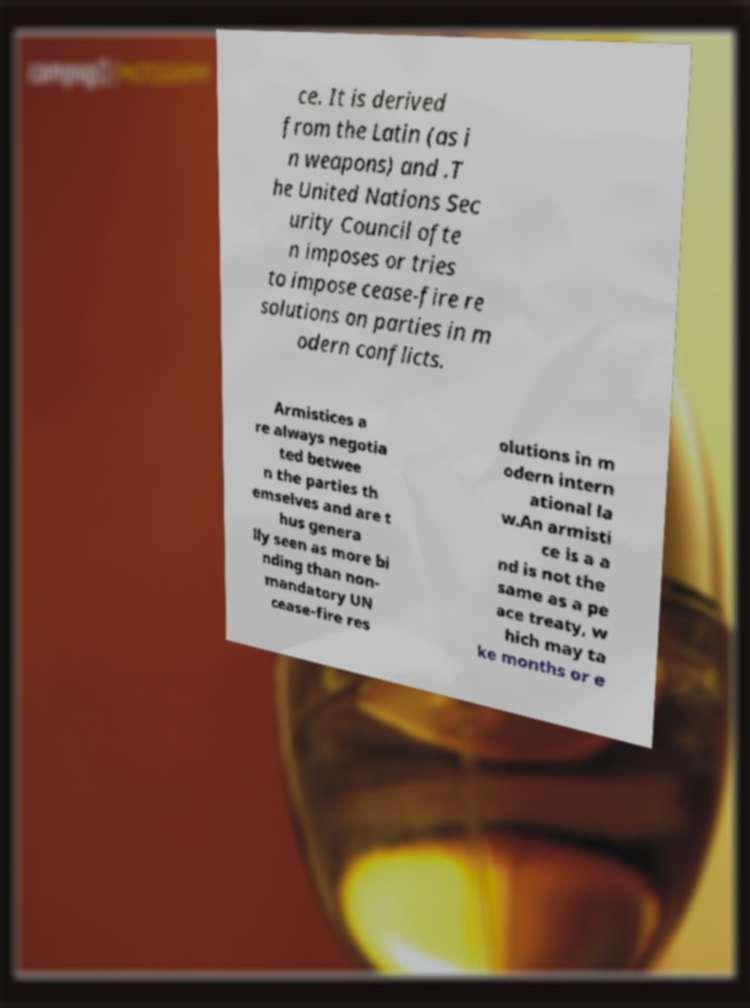I need the written content from this picture converted into text. Can you do that? ce. It is derived from the Latin (as i n weapons) and .T he United Nations Sec urity Council ofte n imposes or tries to impose cease-fire re solutions on parties in m odern conflicts. Armistices a re always negotia ted betwee n the parties th emselves and are t hus genera lly seen as more bi nding than non- mandatory UN cease-fire res olutions in m odern intern ational la w.An armisti ce is a a nd is not the same as a pe ace treaty, w hich may ta ke months or e 